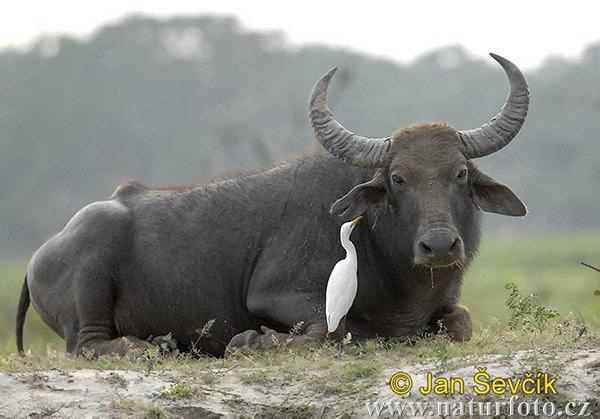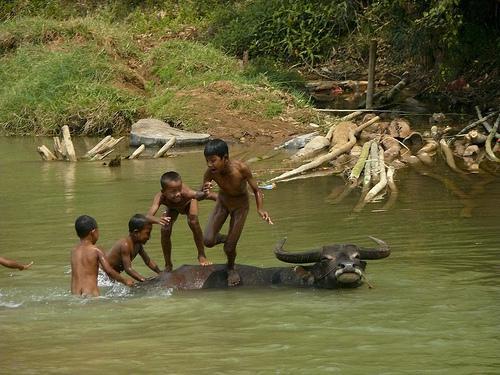The first image is the image on the left, the second image is the image on the right. Considering the images on both sides, is "There is at least one human child in one of the images." valid? Answer yes or no. Yes. The first image is the image on the left, the second image is the image on the right. For the images shown, is this caption "At least one young boy is in the water near a water buffalo in one image." true? Answer yes or no. Yes. 